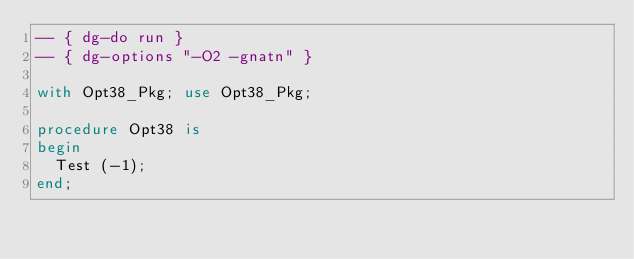<code> <loc_0><loc_0><loc_500><loc_500><_Ada_>-- { dg-do run }
-- { dg-options "-O2 -gnatn" }

with Opt38_Pkg; use Opt38_Pkg;

procedure Opt38 is
begin
  Test (-1);
end;
</code> 